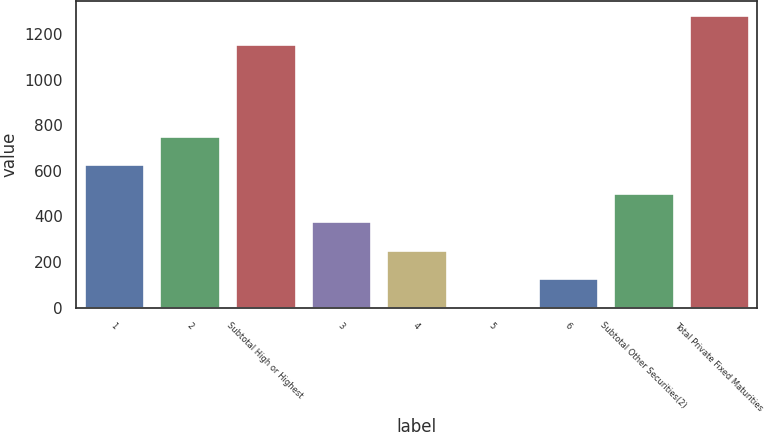<chart> <loc_0><loc_0><loc_500><loc_500><bar_chart><fcel>1<fcel>2<fcel>Subtotal High or Highest<fcel>3<fcel>4<fcel>5<fcel>6<fcel>Subtotal Other Securities(2)<fcel>Total Private Fixed Maturities<nl><fcel>628<fcel>752.4<fcel>1158<fcel>379.2<fcel>254.8<fcel>6<fcel>130.4<fcel>503.6<fcel>1282.4<nl></chart> 